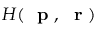<formula> <loc_0><loc_0><loc_500><loc_500>H ( p , r )</formula> 